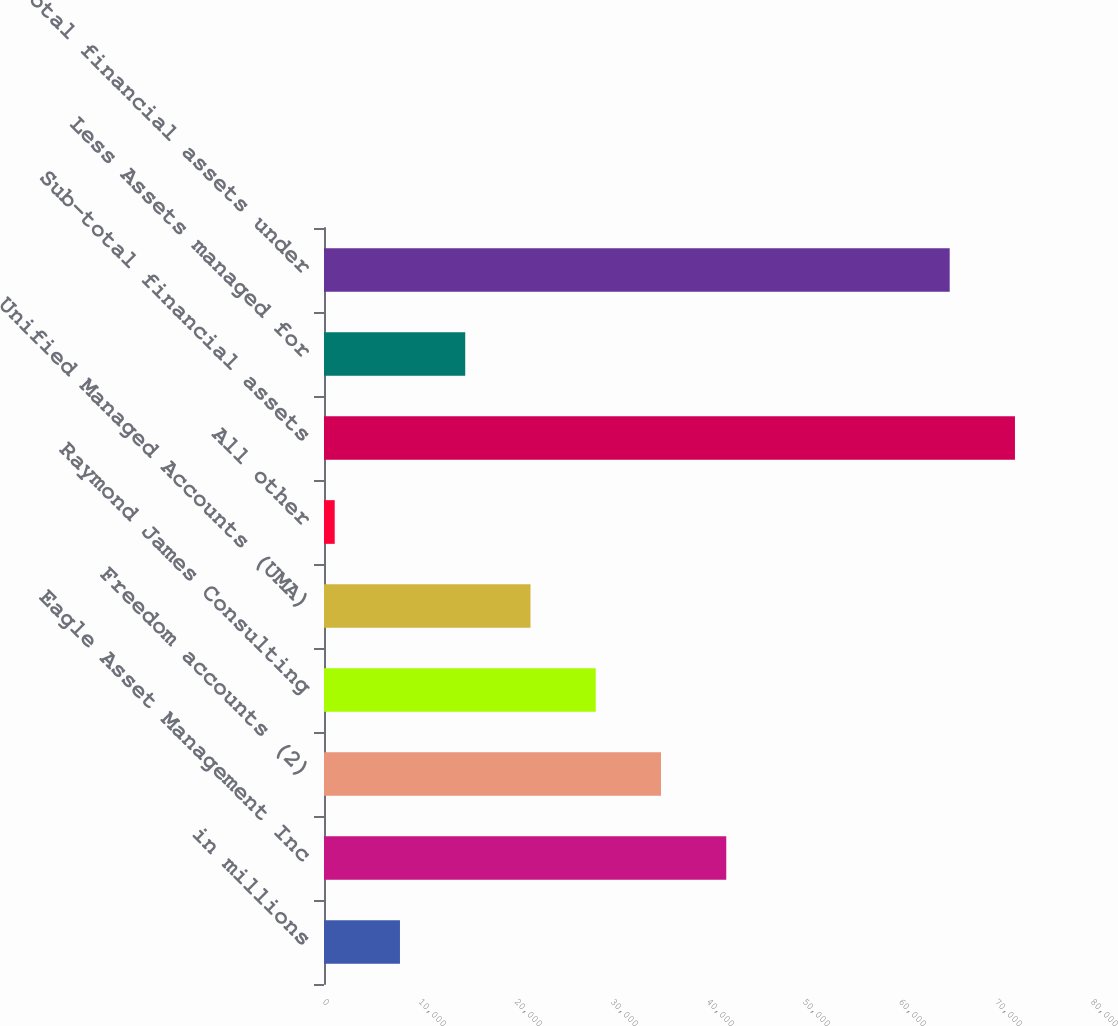<chart> <loc_0><loc_0><loc_500><loc_500><bar_chart><fcel>in millions<fcel>Eagle Asset Management Inc<fcel>Freedom accounts (2)<fcel>Raymond James Consulting<fcel>Unified Managed Accounts (UMA)<fcel>All other<fcel>Sub-total financial assets<fcel>Less Assets managed for<fcel>Total financial assets under<nl><fcel>7913.7<fcel>41902.2<fcel>35104.5<fcel>28306.8<fcel>21509.1<fcel>1116<fcel>71974.7<fcel>14711.4<fcel>65177<nl></chart> 